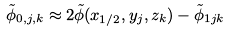Convert formula to latex. <formula><loc_0><loc_0><loc_500><loc_500>\tilde { \phi } _ { 0 , j , k } \approx 2 \tilde { \phi } ( x _ { 1 / 2 } , y _ { j } , z _ { k } ) - \tilde { \phi } _ { 1 j k }</formula> 